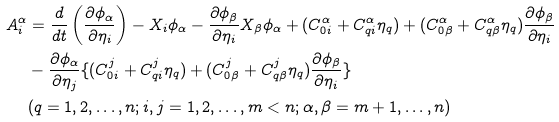<formula> <loc_0><loc_0><loc_500><loc_500>A _ { i } ^ { \alpha } & = \frac { d } { d t } \left ( \frac { \partial \phi _ { \alpha } } { \partial \eta _ { i } } \right ) - X _ { i } \phi _ { \alpha } - \frac { \partial \phi _ { \beta } } { \partial \eta _ { i } } X _ { \beta } \phi _ { \alpha } + ( C _ { 0 i } ^ { \alpha } + C _ { q i } ^ { \alpha } \eta _ { q } ) + ( C _ { 0 \beta } ^ { \alpha } + C _ { q \beta } ^ { \alpha } \eta _ { q } ) \frac { \partial \phi _ { \beta } } { \partial \eta _ { i } } \\ & - \frac { \partial \phi _ { \alpha } } { \partial \eta _ { j } } \{ ( C _ { 0 i } ^ { j } + C _ { q i } ^ { j } \eta _ { q } ) + ( C _ { 0 \beta } ^ { j } + C _ { q \beta } ^ { j } \eta _ { q } ) \frac { \partial \phi _ { \beta } } { \partial \eta _ { i } } \} \\ & ( q = 1 , 2 , \dots , n ; i , j = 1 , 2 , \dots , m < n ; \alpha , \beta = m + 1 , \dots , n )</formula> 